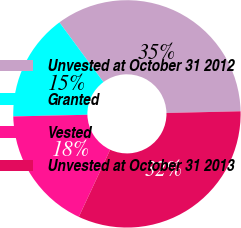Convert chart to OTSL. <chart><loc_0><loc_0><loc_500><loc_500><pie_chart><fcel>Unvested at October 31 2012<fcel>Granted<fcel>Vested<fcel>Unvested at October 31 2013<nl><fcel>34.76%<fcel>15.24%<fcel>17.68%<fcel>32.32%<nl></chart> 